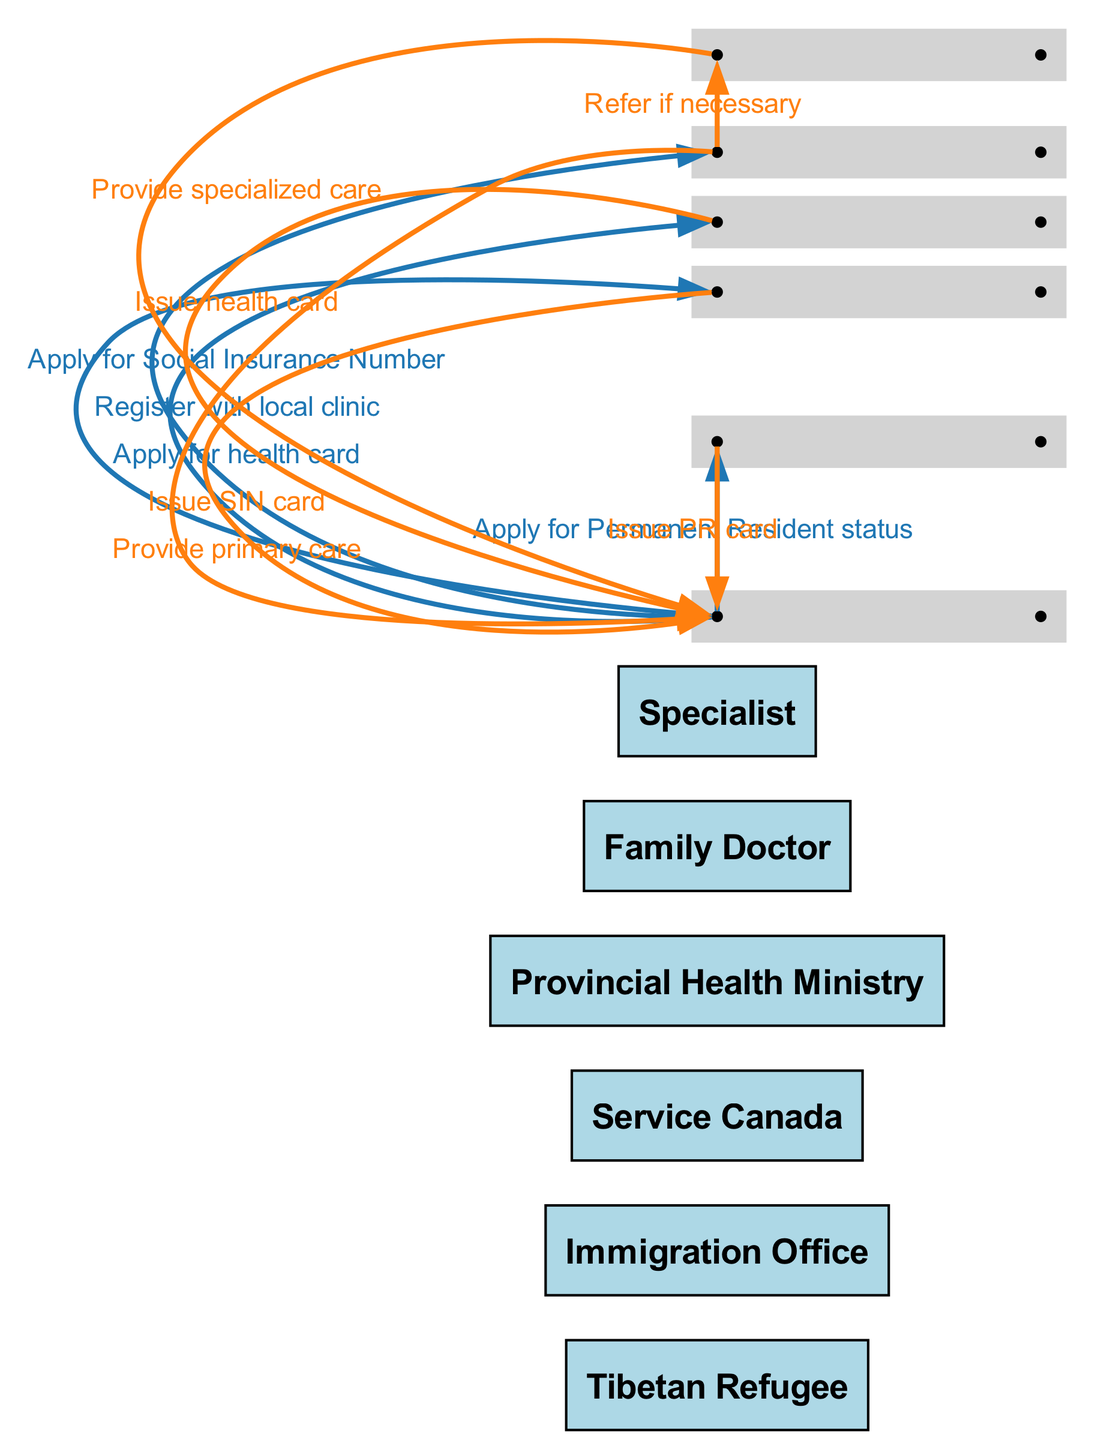What is the first action a Tibetan refugee must take? The diagram indicates that the first action performed by the Tibetan Refugee is "Apply for Permanent Resident status" which is the initial step in their healthcare navigation process.
Answer: Apply for Permanent Resident status Who issues the health card? According to the diagram, the Provincial Health Ministry is responsible for issuing the health card to the Tibetan Refugee after their application.
Answer: Provincial Health Ministry What is the total number of actors involved in this sequence? By counting the actors listed in the diagram, the total number of individuals involved is six: Tibetan Refugee, Immigration Office, Service Canada, Provincial Health Ministry, Family Doctor, and Specialist.
Answer: Six What action comes after obtaining a health card? After the Tibetan Refugee receives the health card from the Provincial Health Ministry, the next step is to "Register with local clinic" where they will connect with a Family Doctor.
Answer: Register with local clinic Which actor provides specialized care? The diagram indicates that the Specialist is the actor who provides specialized care to the Tibetan Refugee, following a referral from the Family Doctor.
Answer: Specialist How many actions involve the Tibetan Refugee? The sequence shows that the Tibetan Refugee participates in five distinct actions from applying for Permanent Resident status to accessing specialized care indirectly through the Family Doctor.
Answer: Five What is the purpose of the referral action? The diagram illustrates that the purpose of the referral from the Family Doctor to the Specialist is necessary to ensure that the Tibetan Refugee receives specialized care if it's deemed necessary.
Answer: To ensure specialized care Which two actors are involved in applying for a Social Insurance Number? The diagram specifies that the Tibetan Refugee applies for the Social Insurance Number through Service Canada, making these the two actors involved in this action.
Answer: Tibetan Refugee, Service Canada 